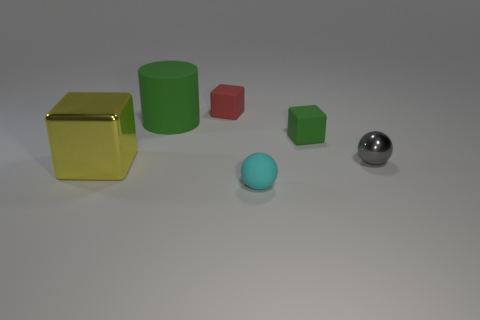What size is the matte thing that is the same color as the big matte cylinder?
Provide a succinct answer. Small. There is a green matte object that is right of the green cylinder; does it have the same shape as the small cyan object?
Make the answer very short. No. Is the number of metal cubes that are on the right side of the large green cylinder greater than the number of tiny gray balls in front of the large yellow thing?
Give a very brief answer. No. How many objects are right of the thing that is behind the cylinder?
Your answer should be compact. 3. What is the material of the cube that is the same color as the large rubber cylinder?
Offer a terse response. Rubber. What number of other objects are there of the same color as the tiny shiny ball?
Provide a succinct answer. 0. What is the color of the large metal object that is in front of the green rubber object in front of the green matte cylinder?
Your response must be concise. Yellow. Are there any other large blocks that have the same color as the metal cube?
Provide a short and direct response. No. Are there the same number of cyan metallic spheres and large yellow things?
Keep it short and to the point. No. What number of metallic objects are tiny green blocks or large green cylinders?
Provide a short and direct response. 0. 